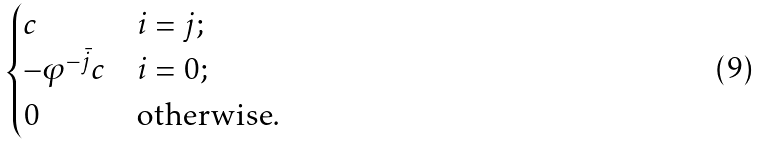Convert formula to latex. <formula><loc_0><loc_0><loc_500><loc_500>\begin{cases} c & i = j ; \\ - \varphi ^ { - \bar { j } } c & i = 0 ; \\ 0 & \text {otherwise} . \end{cases}</formula> 